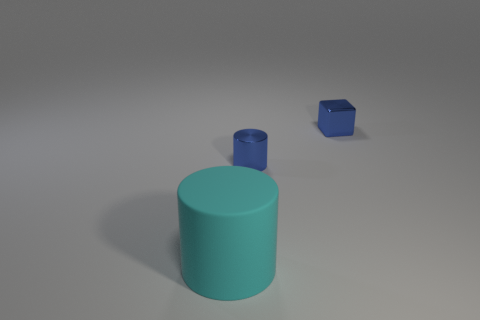Is there any other thing that is the same size as the cyan cylinder?
Ensure brevity in your answer.  No. How many metal cylinders are on the right side of the tiny blue cylinder?
Offer a very short reply. 0. What shape is the small blue metal thing left of the small blue shiny thing that is right of the tiny cylinder?
Provide a succinct answer. Cylinder. Is there any other thing that has the same shape as the rubber thing?
Make the answer very short. Yes. Is the number of big cyan rubber cylinders that are left of the tiny shiny cylinder greater than the number of large rubber cylinders?
Your response must be concise. No. There is a small blue thing that is in front of the block; how many cubes are to the left of it?
Your answer should be compact. 0. What shape is the tiny blue metal object to the left of the small blue shiny thing that is behind the small blue thing that is left of the shiny block?
Give a very brief answer. Cylinder. Are there an equal number of small rubber cylinders and tiny blue cylinders?
Offer a terse response. No. How big is the rubber object?
Make the answer very short. Large. Is there a small cylinder that has the same material as the large cyan object?
Your answer should be compact. No. 